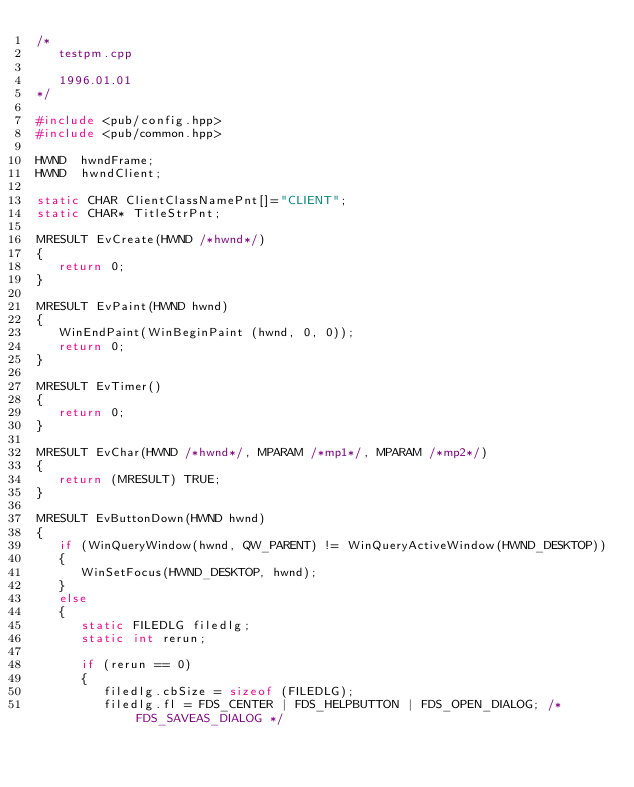<code> <loc_0><loc_0><loc_500><loc_500><_C++_>/*
   testpm.cpp

   1996.01.01
*/

#include <pub/config.hpp>
#include <pub/common.hpp>

HWND  hwndFrame;
HWND  hwndClient;

static CHAR ClientClassNamePnt[]="CLIENT";
static CHAR* TitleStrPnt;

MRESULT EvCreate(HWND /*hwnd*/)
{
   return 0;
}

MRESULT EvPaint(HWND hwnd)
{
   WinEndPaint(WinBeginPaint (hwnd, 0, 0));
   return 0;
}

MRESULT EvTimer()
{
   return 0;
}

MRESULT EvChar(HWND /*hwnd*/, MPARAM /*mp1*/, MPARAM /*mp2*/)
{
   return (MRESULT) TRUE;
}

MRESULT EvButtonDown(HWND hwnd)
{
   if (WinQueryWindow(hwnd, QW_PARENT) != WinQueryActiveWindow(HWND_DESKTOP))
   {
      WinSetFocus(HWND_DESKTOP, hwnd);
   }
   else
   {
      static FILEDLG filedlg;
      static int rerun;

      if (rerun == 0)
      {
         filedlg.cbSize = sizeof (FILEDLG);
         filedlg.fl = FDS_CENTER | FDS_HELPBUTTON | FDS_OPEN_DIALOG; /* FDS_SAVEAS_DIALOG */</code> 